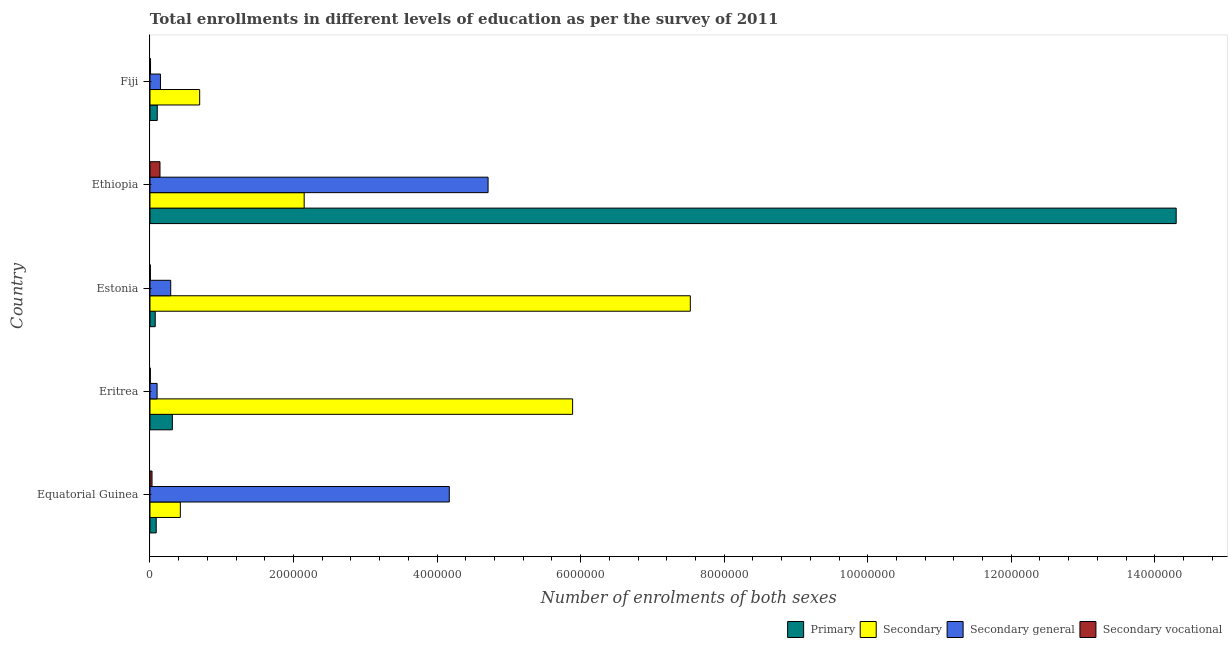Are the number of bars per tick equal to the number of legend labels?
Offer a terse response. Yes. Are the number of bars on each tick of the Y-axis equal?
Give a very brief answer. Yes. What is the label of the 5th group of bars from the top?
Offer a terse response. Equatorial Guinea. What is the number of enrolments in secondary vocational education in Estonia?
Keep it short and to the point. 5330. Across all countries, what is the maximum number of enrolments in secondary general education?
Provide a short and direct response. 4.71e+06. Across all countries, what is the minimum number of enrolments in secondary education?
Give a very brief answer. 4.23e+05. In which country was the number of enrolments in secondary vocational education maximum?
Your response must be concise. Ethiopia. In which country was the number of enrolments in secondary education minimum?
Provide a succinct answer. Equatorial Guinea. What is the total number of enrolments in secondary education in the graph?
Your response must be concise. 1.67e+07. What is the difference between the number of enrolments in secondary education in Eritrea and that in Ethiopia?
Offer a terse response. 3.74e+06. What is the difference between the number of enrolments in primary education in Fiji and the number of enrolments in secondary general education in Equatorial Guinea?
Make the answer very short. -4.07e+06. What is the average number of enrolments in secondary education per country?
Give a very brief answer. 3.34e+06. What is the difference between the number of enrolments in secondary vocational education and number of enrolments in secondary education in Eritrea?
Your response must be concise. -5.88e+06. In how many countries, is the number of enrolments in secondary vocational education greater than 2000000 ?
Your answer should be compact. 0. What is the ratio of the number of enrolments in secondary general education in Eritrea to that in Fiji?
Provide a short and direct response. 0.68. Is the difference between the number of enrolments in secondary general education in Eritrea and Fiji greater than the difference between the number of enrolments in secondary vocational education in Eritrea and Fiji?
Give a very brief answer. No. What is the difference between the highest and the second highest number of enrolments in primary education?
Offer a terse response. 1.40e+07. What is the difference between the highest and the lowest number of enrolments in primary education?
Your answer should be very brief. 1.42e+07. Is the sum of the number of enrolments in primary education in Equatorial Guinea and Fiji greater than the maximum number of enrolments in secondary general education across all countries?
Offer a very short reply. No. What does the 3rd bar from the top in Estonia represents?
Your answer should be very brief. Secondary. What does the 2nd bar from the bottom in Estonia represents?
Provide a succinct answer. Secondary. Are all the bars in the graph horizontal?
Make the answer very short. Yes. What is the difference between two consecutive major ticks on the X-axis?
Provide a succinct answer. 2.00e+06. Does the graph contain grids?
Offer a terse response. No. Where does the legend appear in the graph?
Offer a terse response. Bottom right. How are the legend labels stacked?
Your answer should be very brief. Horizontal. What is the title of the graph?
Your answer should be very brief. Total enrollments in different levels of education as per the survey of 2011. Does "Norway" appear as one of the legend labels in the graph?
Make the answer very short. No. What is the label or title of the X-axis?
Make the answer very short. Number of enrolments of both sexes. What is the Number of enrolments of both sexes of Primary in Equatorial Guinea?
Your answer should be very brief. 8.68e+04. What is the Number of enrolments of both sexes of Secondary in Equatorial Guinea?
Your answer should be very brief. 4.23e+05. What is the Number of enrolments of both sexes of Secondary general in Equatorial Guinea?
Provide a succinct answer. 4.17e+06. What is the Number of enrolments of both sexes in Secondary vocational in Equatorial Guinea?
Offer a very short reply. 2.84e+04. What is the Number of enrolments of both sexes in Primary in Eritrea?
Your response must be concise. 3.12e+05. What is the Number of enrolments of both sexes of Secondary in Eritrea?
Your answer should be compact. 5.89e+06. What is the Number of enrolments of both sexes of Secondary general in Eritrea?
Make the answer very short. 9.89e+04. What is the Number of enrolments of both sexes in Secondary vocational in Eritrea?
Your answer should be very brief. 4541. What is the Number of enrolments of both sexes in Primary in Estonia?
Provide a succinct answer. 7.31e+04. What is the Number of enrolments of both sexes of Secondary in Estonia?
Your response must be concise. 7.53e+06. What is the Number of enrolments of both sexes in Secondary general in Estonia?
Offer a terse response. 2.89e+05. What is the Number of enrolments of both sexes of Secondary vocational in Estonia?
Your answer should be compact. 5330. What is the Number of enrolments of both sexes of Primary in Ethiopia?
Offer a terse response. 1.43e+07. What is the Number of enrolments of both sexes in Secondary in Ethiopia?
Your answer should be compact. 2.15e+06. What is the Number of enrolments of both sexes of Secondary general in Ethiopia?
Your response must be concise. 4.71e+06. What is the Number of enrolments of both sexes of Secondary vocational in Ethiopia?
Offer a very short reply. 1.39e+05. What is the Number of enrolments of both sexes in Primary in Fiji?
Make the answer very short. 1.01e+05. What is the Number of enrolments of both sexes in Secondary in Fiji?
Your answer should be very brief. 6.92e+05. What is the Number of enrolments of both sexes of Secondary general in Fiji?
Ensure brevity in your answer.  1.46e+05. What is the Number of enrolments of both sexes in Secondary vocational in Fiji?
Provide a succinct answer. 7629. Across all countries, what is the maximum Number of enrolments of both sexes of Primary?
Provide a short and direct response. 1.43e+07. Across all countries, what is the maximum Number of enrolments of both sexes of Secondary?
Make the answer very short. 7.53e+06. Across all countries, what is the maximum Number of enrolments of both sexes of Secondary general?
Give a very brief answer. 4.71e+06. Across all countries, what is the maximum Number of enrolments of both sexes in Secondary vocational?
Your answer should be compact. 1.39e+05. Across all countries, what is the minimum Number of enrolments of both sexes in Primary?
Offer a very short reply. 7.31e+04. Across all countries, what is the minimum Number of enrolments of both sexes of Secondary?
Keep it short and to the point. 4.23e+05. Across all countries, what is the minimum Number of enrolments of both sexes of Secondary general?
Offer a very short reply. 9.89e+04. Across all countries, what is the minimum Number of enrolments of both sexes of Secondary vocational?
Your answer should be compact. 4541. What is the total Number of enrolments of both sexes in Primary in the graph?
Your answer should be compact. 1.49e+07. What is the total Number of enrolments of both sexes of Secondary in the graph?
Your answer should be compact. 1.67e+07. What is the total Number of enrolments of both sexes in Secondary general in the graph?
Provide a succinct answer. 9.41e+06. What is the total Number of enrolments of both sexes of Secondary vocational in the graph?
Give a very brief answer. 1.85e+05. What is the difference between the Number of enrolments of both sexes of Primary in Equatorial Guinea and that in Eritrea?
Provide a short and direct response. -2.25e+05. What is the difference between the Number of enrolments of both sexes in Secondary in Equatorial Guinea and that in Eritrea?
Provide a short and direct response. -5.47e+06. What is the difference between the Number of enrolments of both sexes in Secondary general in Equatorial Guinea and that in Eritrea?
Your response must be concise. 4.07e+06. What is the difference between the Number of enrolments of both sexes of Secondary vocational in Equatorial Guinea and that in Eritrea?
Give a very brief answer. 2.38e+04. What is the difference between the Number of enrolments of both sexes in Primary in Equatorial Guinea and that in Estonia?
Ensure brevity in your answer.  1.38e+04. What is the difference between the Number of enrolments of both sexes of Secondary in Equatorial Guinea and that in Estonia?
Your response must be concise. -7.11e+06. What is the difference between the Number of enrolments of both sexes of Secondary general in Equatorial Guinea and that in Estonia?
Ensure brevity in your answer.  3.88e+06. What is the difference between the Number of enrolments of both sexes of Secondary vocational in Equatorial Guinea and that in Estonia?
Offer a terse response. 2.30e+04. What is the difference between the Number of enrolments of both sexes in Primary in Equatorial Guinea and that in Ethiopia?
Your answer should be compact. -1.42e+07. What is the difference between the Number of enrolments of both sexes of Secondary in Equatorial Guinea and that in Ethiopia?
Your response must be concise. -1.73e+06. What is the difference between the Number of enrolments of both sexes in Secondary general in Equatorial Guinea and that in Ethiopia?
Give a very brief answer. -5.40e+05. What is the difference between the Number of enrolments of both sexes in Secondary vocational in Equatorial Guinea and that in Ethiopia?
Your response must be concise. -1.11e+05. What is the difference between the Number of enrolments of both sexes of Primary in Equatorial Guinea and that in Fiji?
Make the answer very short. -1.46e+04. What is the difference between the Number of enrolments of both sexes in Secondary in Equatorial Guinea and that in Fiji?
Ensure brevity in your answer.  -2.69e+05. What is the difference between the Number of enrolments of both sexes of Secondary general in Equatorial Guinea and that in Fiji?
Ensure brevity in your answer.  4.02e+06. What is the difference between the Number of enrolments of both sexes in Secondary vocational in Equatorial Guinea and that in Fiji?
Offer a very short reply. 2.07e+04. What is the difference between the Number of enrolments of both sexes in Primary in Eritrea and that in Estonia?
Offer a very short reply. 2.39e+05. What is the difference between the Number of enrolments of both sexes of Secondary in Eritrea and that in Estonia?
Ensure brevity in your answer.  -1.64e+06. What is the difference between the Number of enrolments of both sexes in Secondary general in Eritrea and that in Estonia?
Make the answer very short. -1.90e+05. What is the difference between the Number of enrolments of both sexes in Secondary vocational in Eritrea and that in Estonia?
Provide a short and direct response. -789. What is the difference between the Number of enrolments of both sexes in Primary in Eritrea and that in Ethiopia?
Offer a very short reply. -1.40e+07. What is the difference between the Number of enrolments of both sexes in Secondary in Eritrea and that in Ethiopia?
Offer a very short reply. 3.74e+06. What is the difference between the Number of enrolments of both sexes in Secondary general in Eritrea and that in Ethiopia?
Make the answer very short. -4.61e+06. What is the difference between the Number of enrolments of both sexes of Secondary vocational in Eritrea and that in Ethiopia?
Your response must be concise. -1.35e+05. What is the difference between the Number of enrolments of both sexes in Primary in Eritrea and that in Fiji?
Make the answer very short. 2.10e+05. What is the difference between the Number of enrolments of both sexes of Secondary in Eritrea and that in Fiji?
Your response must be concise. 5.20e+06. What is the difference between the Number of enrolments of both sexes of Secondary general in Eritrea and that in Fiji?
Provide a short and direct response. -4.72e+04. What is the difference between the Number of enrolments of both sexes of Secondary vocational in Eritrea and that in Fiji?
Your answer should be compact. -3088. What is the difference between the Number of enrolments of both sexes of Primary in Estonia and that in Ethiopia?
Provide a succinct answer. -1.42e+07. What is the difference between the Number of enrolments of both sexes of Secondary in Estonia and that in Ethiopia?
Offer a very short reply. 5.38e+06. What is the difference between the Number of enrolments of both sexes in Secondary general in Estonia and that in Ethiopia?
Your answer should be compact. -4.42e+06. What is the difference between the Number of enrolments of both sexes of Secondary vocational in Estonia and that in Ethiopia?
Keep it short and to the point. -1.34e+05. What is the difference between the Number of enrolments of both sexes in Primary in Estonia and that in Fiji?
Provide a short and direct response. -2.83e+04. What is the difference between the Number of enrolments of both sexes in Secondary in Estonia and that in Fiji?
Your answer should be compact. 6.84e+06. What is the difference between the Number of enrolments of both sexes in Secondary general in Estonia and that in Fiji?
Offer a terse response. 1.43e+05. What is the difference between the Number of enrolments of both sexes in Secondary vocational in Estonia and that in Fiji?
Offer a very short reply. -2299. What is the difference between the Number of enrolments of both sexes in Primary in Ethiopia and that in Fiji?
Offer a terse response. 1.42e+07. What is the difference between the Number of enrolments of both sexes in Secondary in Ethiopia and that in Fiji?
Your answer should be compact. 1.46e+06. What is the difference between the Number of enrolments of both sexes in Secondary general in Ethiopia and that in Fiji?
Keep it short and to the point. 4.56e+06. What is the difference between the Number of enrolments of both sexes in Secondary vocational in Ethiopia and that in Fiji?
Your response must be concise. 1.32e+05. What is the difference between the Number of enrolments of both sexes of Primary in Equatorial Guinea and the Number of enrolments of both sexes of Secondary in Eritrea?
Your answer should be very brief. -5.80e+06. What is the difference between the Number of enrolments of both sexes of Primary in Equatorial Guinea and the Number of enrolments of both sexes of Secondary general in Eritrea?
Your answer should be compact. -1.21e+04. What is the difference between the Number of enrolments of both sexes in Primary in Equatorial Guinea and the Number of enrolments of both sexes in Secondary vocational in Eritrea?
Your answer should be very brief. 8.23e+04. What is the difference between the Number of enrolments of both sexes of Secondary in Equatorial Guinea and the Number of enrolments of both sexes of Secondary general in Eritrea?
Your response must be concise. 3.24e+05. What is the difference between the Number of enrolments of both sexes in Secondary in Equatorial Guinea and the Number of enrolments of both sexes in Secondary vocational in Eritrea?
Your answer should be compact. 4.18e+05. What is the difference between the Number of enrolments of both sexes in Secondary general in Equatorial Guinea and the Number of enrolments of both sexes in Secondary vocational in Eritrea?
Your answer should be very brief. 4.17e+06. What is the difference between the Number of enrolments of both sexes in Primary in Equatorial Guinea and the Number of enrolments of both sexes in Secondary in Estonia?
Offer a terse response. -7.44e+06. What is the difference between the Number of enrolments of both sexes in Primary in Equatorial Guinea and the Number of enrolments of both sexes in Secondary general in Estonia?
Offer a terse response. -2.02e+05. What is the difference between the Number of enrolments of both sexes of Primary in Equatorial Guinea and the Number of enrolments of both sexes of Secondary vocational in Estonia?
Your response must be concise. 8.15e+04. What is the difference between the Number of enrolments of both sexes of Secondary in Equatorial Guinea and the Number of enrolments of both sexes of Secondary general in Estonia?
Keep it short and to the point. 1.34e+05. What is the difference between the Number of enrolments of both sexes of Secondary in Equatorial Guinea and the Number of enrolments of both sexes of Secondary vocational in Estonia?
Give a very brief answer. 4.18e+05. What is the difference between the Number of enrolments of both sexes in Secondary general in Equatorial Guinea and the Number of enrolments of both sexes in Secondary vocational in Estonia?
Keep it short and to the point. 4.16e+06. What is the difference between the Number of enrolments of both sexes of Primary in Equatorial Guinea and the Number of enrolments of both sexes of Secondary in Ethiopia?
Offer a very short reply. -2.06e+06. What is the difference between the Number of enrolments of both sexes of Primary in Equatorial Guinea and the Number of enrolments of both sexes of Secondary general in Ethiopia?
Offer a terse response. -4.62e+06. What is the difference between the Number of enrolments of both sexes in Primary in Equatorial Guinea and the Number of enrolments of both sexes in Secondary vocational in Ethiopia?
Make the answer very short. -5.25e+04. What is the difference between the Number of enrolments of both sexes of Secondary in Equatorial Guinea and the Number of enrolments of both sexes of Secondary general in Ethiopia?
Offer a very short reply. -4.29e+06. What is the difference between the Number of enrolments of both sexes in Secondary in Equatorial Guinea and the Number of enrolments of both sexes in Secondary vocational in Ethiopia?
Offer a very short reply. 2.84e+05. What is the difference between the Number of enrolments of both sexes in Secondary general in Equatorial Guinea and the Number of enrolments of both sexes in Secondary vocational in Ethiopia?
Your answer should be compact. 4.03e+06. What is the difference between the Number of enrolments of both sexes in Primary in Equatorial Guinea and the Number of enrolments of both sexes in Secondary in Fiji?
Your answer should be compact. -6.05e+05. What is the difference between the Number of enrolments of both sexes in Primary in Equatorial Guinea and the Number of enrolments of both sexes in Secondary general in Fiji?
Your response must be concise. -5.93e+04. What is the difference between the Number of enrolments of both sexes of Primary in Equatorial Guinea and the Number of enrolments of both sexes of Secondary vocational in Fiji?
Ensure brevity in your answer.  7.92e+04. What is the difference between the Number of enrolments of both sexes of Secondary in Equatorial Guinea and the Number of enrolments of both sexes of Secondary general in Fiji?
Provide a short and direct response. 2.77e+05. What is the difference between the Number of enrolments of both sexes of Secondary in Equatorial Guinea and the Number of enrolments of both sexes of Secondary vocational in Fiji?
Ensure brevity in your answer.  4.15e+05. What is the difference between the Number of enrolments of both sexes in Secondary general in Equatorial Guinea and the Number of enrolments of both sexes in Secondary vocational in Fiji?
Provide a succinct answer. 4.16e+06. What is the difference between the Number of enrolments of both sexes in Primary in Eritrea and the Number of enrolments of both sexes in Secondary in Estonia?
Ensure brevity in your answer.  -7.22e+06. What is the difference between the Number of enrolments of both sexes in Primary in Eritrea and the Number of enrolments of both sexes in Secondary general in Estonia?
Provide a succinct answer. 2.30e+04. What is the difference between the Number of enrolments of both sexes in Primary in Eritrea and the Number of enrolments of both sexes in Secondary vocational in Estonia?
Make the answer very short. 3.06e+05. What is the difference between the Number of enrolments of both sexes in Secondary in Eritrea and the Number of enrolments of both sexes in Secondary general in Estonia?
Make the answer very short. 5.60e+06. What is the difference between the Number of enrolments of both sexes in Secondary in Eritrea and the Number of enrolments of both sexes in Secondary vocational in Estonia?
Keep it short and to the point. 5.88e+06. What is the difference between the Number of enrolments of both sexes of Secondary general in Eritrea and the Number of enrolments of both sexes of Secondary vocational in Estonia?
Your answer should be very brief. 9.36e+04. What is the difference between the Number of enrolments of both sexes of Primary in Eritrea and the Number of enrolments of both sexes of Secondary in Ethiopia?
Your answer should be very brief. -1.84e+06. What is the difference between the Number of enrolments of both sexes of Primary in Eritrea and the Number of enrolments of both sexes of Secondary general in Ethiopia?
Your response must be concise. -4.40e+06. What is the difference between the Number of enrolments of both sexes in Primary in Eritrea and the Number of enrolments of both sexes in Secondary vocational in Ethiopia?
Keep it short and to the point. 1.72e+05. What is the difference between the Number of enrolments of both sexes of Secondary in Eritrea and the Number of enrolments of both sexes of Secondary general in Ethiopia?
Provide a short and direct response. 1.18e+06. What is the difference between the Number of enrolments of both sexes in Secondary in Eritrea and the Number of enrolments of both sexes in Secondary vocational in Ethiopia?
Your answer should be very brief. 5.75e+06. What is the difference between the Number of enrolments of both sexes in Secondary general in Eritrea and the Number of enrolments of both sexes in Secondary vocational in Ethiopia?
Make the answer very short. -4.04e+04. What is the difference between the Number of enrolments of both sexes in Primary in Eritrea and the Number of enrolments of both sexes in Secondary in Fiji?
Give a very brief answer. -3.81e+05. What is the difference between the Number of enrolments of both sexes in Primary in Eritrea and the Number of enrolments of both sexes in Secondary general in Fiji?
Your answer should be compact. 1.66e+05. What is the difference between the Number of enrolments of both sexes in Primary in Eritrea and the Number of enrolments of both sexes in Secondary vocational in Fiji?
Provide a succinct answer. 3.04e+05. What is the difference between the Number of enrolments of both sexes of Secondary in Eritrea and the Number of enrolments of both sexes of Secondary general in Fiji?
Ensure brevity in your answer.  5.74e+06. What is the difference between the Number of enrolments of both sexes of Secondary in Eritrea and the Number of enrolments of both sexes of Secondary vocational in Fiji?
Your answer should be compact. 5.88e+06. What is the difference between the Number of enrolments of both sexes in Secondary general in Eritrea and the Number of enrolments of both sexes in Secondary vocational in Fiji?
Provide a succinct answer. 9.13e+04. What is the difference between the Number of enrolments of both sexes in Primary in Estonia and the Number of enrolments of both sexes in Secondary in Ethiopia?
Ensure brevity in your answer.  -2.08e+06. What is the difference between the Number of enrolments of both sexes of Primary in Estonia and the Number of enrolments of both sexes of Secondary general in Ethiopia?
Make the answer very short. -4.64e+06. What is the difference between the Number of enrolments of both sexes in Primary in Estonia and the Number of enrolments of both sexes in Secondary vocational in Ethiopia?
Your answer should be compact. -6.63e+04. What is the difference between the Number of enrolments of both sexes of Secondary in Estonia and the Number of enrolments of both sexes of Secondary general in Ethiopia?
Keep it short and to the point. 2.82e+06. What is the difference between the Number of enrolments of both sexes in Secondary in Estonia and the Number of enrolments of both sexes in Secondary vocational in Ethiopia?
Provide a short and direct response. 7.39e+06. What is the difference between the Number of enrolments of both sexes of Secondary general in Estonia and the Number of enrolments of both sexes of Secondary vocational in Ethiopia?
Offer a terse response. 1.49e+05. What is the difference between the Number of enrolments of both sexes in Primary in Estonia and the Number of enrolments of both sexes in Secondary in Fiji?
Your answer should be very brief. -6.19e+05. What is the difference between the Number of enrolments of both sexes of Primary in Estonia and the Number of enrolments of both sexes of Secondary general in Fiji?
Provide a short and direct response. -7.30e+04. What is the difference between the Number of enrolments of both sexes of Primary in Estonia and the Number of enrolments of both sexes of Secondary vocational in Fiji?
Make the answer very short. 6.54e+04. What is the difference between the Number of enrolments of both sexes of Secondary in Estonia and the Number of enrolments of both sexes of Secondary general in Fiji?
Your response must be concise. 7.38e+06. What is the difference between the Number of enrolments of both sexes in Secondary in Estonia and the Number of enrolments of both sexes in Secondary vocational in Fiji?
Give a very brief answer. 7.52e+06. What is the difference between the Number of enrolments of both sexes in Secondary general in Estonia and the Number of enrolments of both sexes in Secondary vocational in Fiji?
Your answer should be compact. 2.81e+05. What is the difference between the Number of enrolments of both sexes in Primary in Ethiopia and the Number of enrolments of both sexes in Secondary in Fiji?
Offer a terse response. 1.36e+07. What is the difference between the Number of enrolments of both sexes in Primary in Ethiopia and the Number of enrolments of both sexes in Secondary general in Fiji?
Your answer should be compact. 1.42e+07. What is the difference between the Number of enrolments of both sexes in Primary in Ethiopia and the Number of enrolments of both sexes in Secondary vocational in Fiji?
Your answer should be very brief. 1.43e+07. What is the difference between the Number of enrolments of both sexes of Secondary in Ethiopia and the Number of enrolments of both sexes of Secondary general in Fiji?
Ensure brevity in your answer.  2.00e+06. What is the difference between the Number of enrolments of both sexes of Secondary in Ethiopia and the Number of enrolments of both sexes of Secondary vocational in Fiji?
Provide a succinct answer. 2.14e+06. What is the difference between the Number of enrolments of both sexes of Secondary general in Ethiopia and the Number of enrolments of both sexes of Secondary vocational in Fiji?
Offer a terse response. 4.70e+06. What is the average Number of enrolments of both sexes of Primary per country?
Offer a very short reply. 2.97e+06. What is the average Number of enrolments of both sexes of Secondary per country?
Offer a very short reply. 3.34e+06. What is the average Number of enrolments of both sexes in Secondary general per country?
Keep it short and to the point. 1.88e+06. What is the average Number of enrolments of both sexes of Secondary vocational per country?
Keep it short and to the point. 3.70e+04. What is the difference between the Number of enrolments of both sexes in Primary and Number of enrolments of both sexes in Secondary in Equatorial Guinea?
Your answer should be very brief. -3.36e+05. What is the difference between the Number of enrolments of both sexes in Primary and Number of enrolments of both sexes in Secondary general in Equatorial Guinea?
Offer a terse response. -4.08e+06. What is the difference between the Number of enrolments of both sexes in Primary and Number of enrolments of both sexes in Secondary vocational in Equatorial Guinea?
Give a very brief answer. 5.84e+04. What is the difference between the Number of enrolments of both sexes of Secondary and Number of enrolments of both sexes of Secondary general in Equatorial Guinea?
Provide a short and direct response. -3.75e+06. What is the difference between the Number of enrolments of both sexes in Secondary and Number of enrolments of both sexes in Secondary vocational in Equatorial Guinea?
Ensure brevity in your answer.  3.95e+05. What is the difference between the Number of enrolments of both sexes of Secondary general and Number of enrolments of both sexes of Secondary vocational in Equatorial Guinea?
Provide a short and direct response. 4.14e+06. What is the difference between the Number of enrolments of both sexes in Primary and Number of enrolments of both sexes in Secondary in Eritrea?
Offer a terse response. -5.58e+06. What is the difference between the Number of enrolments of both sexes in Primary and Number of enrolments of both sexes in Secondary general in Eritrea?
Provide a succinct answer. 2.13e+05. What is the difference between the Number of enrolments of both sexes of Primary and Number of enrolments of both sexes of Secondary vocational in Eritrea?
Offer a very short reply. 3.07e+05. What is the difference between the Number of enrolments of both sexes of Secondary and Number of enrolments of both sexes of Secondary general in Eritrea?
Give a very brief answer. 5.79e+06. What is the difference between the Number of enrolments of both sexes of Secondary and Number of enrolments of both sexes of Secondary vocational in Eritrea?
Your answer should be very brief. 5.88e+06. What is the difference between the Number of enrolments of both sexes of Secondary general and Number of enrolments of both sexes of Secondary vocational in Eritrea?
Your answer should be very brief. 9.43e+04. What is the difference between the Number of enrolments of both sexes of Primary and Number of enrolments of both sexes of Secondary in Estonia?
Your answer should be compact. -7.46e+06. What is the difference between the Number of enrolments of both sexes of Primary and Number of enrolments of both sexes of Secondary general in Estonia?
Your answer should be compact. -2.16e+05. What is the difference between the Number of enrolments of both sexes in Primary and Number of enrolments of both sexes in Secondary vocational in Estonia?
Your answer should be compact. 6.77e+04. What is the difference between the Number of enrolments of both sexes in Secondary and Number of enrolments of both sexes in Secondary general in Estonia?
Keep it short and to the point. 7.24e+06. What is the difference between the Number of enrolments of both sexes in Secondary and Number of enrolments of both sexes in Secondary vocational in Estonia?
Make the answer very short. 7.52e+06. What is the difference between the Number of enrolments of both sexes of Secondary general and Number of enrolments of both sexes of Secondary vocational in Estonia?
Ensure brevity in your answer.  2.83e+05. What is the difference between the Number of enrolments of both sexes of Primary and Number of enrolments of both sexes of Secondary in Ethiopia?
Your answer should be very brief. 1.21e+07. What is the difference between the Number of enrolments of both sexes in Primary and Number of enrolments of both sexes in Secondary general in Ethiopia?
Provide a succinct answer. 9.59e+06. What is the difference between the Number of enrolments of both sexes in Primary and Number of enrolments of both sexes in Secondary vocational in Ethiopia?
Make the answer very short. 1.42e+07. What is the difference between the Number of enrolments of both sexes of Secondary and Number of enrolments of both sexes of Secondary general in Ethiopia?
Offer a very short reply. -2.56e+06. What is the difference between the Number of enrolments of both sexes in Secondary and Number of enrolments of both sexes in Secondary vocational in Ethiopia?
Ensure brevity in your answer.  2.01e+06. What is the difference between the Number of enrolments of both sexes in Secondary general and Number of enrolments of both sexes in Secondary vocational in Ethiopia?
Offer a terse response. 4.57e+06. What is the difference between the Number of enrolments of both sexes in Primary and Number of enrolments of both sexes in Secondary in Fiji?
Your answer should be compact. -5.91e+05. What is the difference between the Number of enrolments of both sexes in Primary and Number of enrolments of both sexes in Secondary general in Fiji?
Offer a very short reply. -4.47e+04. What is the difference between the Number of enrolments of both sexes in Primary and Number of enrolments of both sexes in Secondary vocational in Fiji?
Your response must be concise. 9.38e+04. What is the difference between the Number of enrolments of both sexes in Secondary and Number of enrolments of both sexes in Secondary general in Fiji?
Offer a terse response. 5.46e+05. What is the difference between the Number of enrolments of both sexes of Secondary and Number of enrolments of both sexes of Secondary vocational in Fiji?
Your answer should be compact. 6.85e+05. What is the difference between the Number of enrolments of both sexes of Secondary general and Number of enrolments of both sexes of Secondary vocational in Fiji?
Provide a succinct answer. 1.38e+05. What is the ratio of the Number of enrolments of both sexes of Primary in Equatorial Guinea to that in Eritrea?
Your answer should be compact. 0.28. What is the ratio of the Number of enrolments of both sexes in Secondary in Equatorial Guinea to that in Eritrea?
Offer a very short reply. 0.07. What is the ratio of the Number of enrolments of both sexes of Secondary general in Equatorial Guinea to that in Eritrea?
Your answer should be very brief. 42.17. What is the ratio of the Number of enrolments of both sexes of Secondary vocational in Equatorial Guinea to that in Eritrea?
Your answer should be compact. 6.25. What is the ratio of the Number of enrolments of both sexes of Primary in Equatorial Guinea to that in Estonia?
Give a very brief answer. 1.19. What is the ratio of the Number of enrolments of both sexes in Secondary in Equatorial Guinea to that in Estonia?
Keep it short and to the point. 0.06. What is the ratio of the Number of enrolments of both sexes in Secondary general in Equatorial Guinea to that in Estonia?
Your answer should be very brief. 14.44. What is the ratio of the Number of enrolments of both sexes of Secondary vocational in Equatorial Guinea to that in Estonia?
Your answer should be compact. 5.32. What is the ratio of the Number of enrolments of both sexes in Primary in Equatorial Guinea to that in Ethiopia?
Make the answer very short. 0.01. What is the ratio of the Number of enrolments of both sexes of Secondary in Equatorial Guinea to that in Ethiopia?
Your response must be concise. 0.2. What is the ratio of the Number of enrolments of both sexes of Secondary general in Equatorial Guinea to that in Ethiopia?
Offer a terse response. 0.89. What is the ratio of the Number of enrolments of both sexes of Secondary vocational in Equatorial Guinea to that in Ethiopia?
Ensure brevity in your answer.  0.2. What is the ratio of the Number of enrolments of both sexes of Primary in Equatorial Guinea to that in Fiji?
Ensure brevity in your answer.  0.86. What is the ratio of the Number of enrolments of both sexes of Secondary in Equatorial Guinea to that in Fiji?
Make the answer very short. 0.61. What is the ratio of the Number of enrolments of both sexes of Secondary general in Equatorial Guinea to that in Fiji?
Keep it short and to the point. 28.55. What is the ratio of the Number of enrolments of both sexes in Secondary vocational in Equatorial Guinea to that in Fiji?
Give a very brief answer. 3.72. What is the ratio of the Number of enrolments of both sexes of Primary in Eritrea to that in Estonia?
Make the answer very short. 4.27. What is the ratio of the Number of enrolments of both sexes of Secondary in Eritrea to that in Estonia?
Make the answer very short. 0.78. What is the ratio of the Number of enrolments of both sexes of Secondary general in Eritrea to that in Estonia?
Offer a very short reply. 0.34. What is the ratio of the Number of enrolments of both sexes in Secondary vocational in Eritrea to that in Estonia?
Ensure brevity in your answer.  0.85. What is the ratio of the Number of enrolments of both sexes of Primary in Eritrea to that in Ethiopia?
Offer a very short reply. 0.02. What is the ratio of the Number of enrolments of both sexes in Secondary in Eritrea to that in Ethiopia?
Make the answer very short. 2.74. What is the ratio of the Number of enrolments of both sexes of Secondary general in Eritrea to that in Ethiopia?
Your response must be concise. 0.02. What is the ratio of the Number of enrolments of both sexes of Secondary vocational in Eritrea to that in Ethiopia?
Ensure brevity in your answer.  0.03. What is the ratio of the Number of enrolments of both sexes of Primary in Eritrea to that in Fiji?
Keep it short and to the point. 3.07. What is the ratio of the Number of enrolments of both sexes in Secondary in Eritrea to that in Fiji?
Ensure brevity in your answer.  8.51. What is the ratio of the Number of enrolments of both sexes in Secondary general in Eritrea to that in Fiji?
Your answer should be compact. 0.68. What is the ratio of the Number of enrolments of both sexes of Secondary vocational in Eritrea to that in Fiji?
Keep it short and to the point. 0.6. What is the ratio of the Number of enrolments of both sexes of Primary in Estonia to that in Ethiopia?
Your response must be concise. 0.01. What is the ratio of the Number of enrolments of both sexes in Secondary in Estonia to that in Ethiopia?
Your answer should be very brief. 3.5. What is the ratio of the Number of enrolments of both sexes in Secondary general in Estonia to that in Ethiopia?
Give a very brief answer. 0.06. What is the ratio of the Number of enrolments of both sexes of Secondary vocational in Estonia to that in Ethiopia?
Offer a very short reply. 0.04. What is the ratio of the Number of enrolments of both sexes in Primary in Estonia to that in Fiji?
Your answer should be very brief. 0.72. What is the ratio of the Number of enrolments of both sexes in Secondary in Estonia to that in Fiji?
Keep it short and to the point. 10.87. What is the ratio of the Number of enrolments of both sexes of Secondary general in Estonia to that in Fiji?
Provide a succinct answer. 1.98. What is the ratio of the Number of enrolments of both sexes in Secondary vocational in Estonia to that in Fiji?
Ensure brevity in your answer.  0.7. What is the ratio of the Number of enrolments of both sexes of Primary in Ethiopia to that in Fiji?
Ensure brevity in your answer.  141.03. What is the ratio of the Number of enrolments of both sexes of Secondary in Ethiopia to that in Fiji?
Your answer should be compact. 3.1. What is the ratio of the Number of enrolments of both sexes of Secondary general in Ethiopia to that in Fiji?
Ensure brevity in your answer.  32.25. What is the ratio of the Number of enrolments of both sexes in Secondary vocational in Ethiopia to that in Fiji?
Your answer should be very brief. 18.26. What is the difference between the highest and the second highest Number of enrolments of both sexes in Primary?
Keep it short and to the point. 1.40e+07. What is the difference between the highest and the second highest Number of enrolments of both sexes of Secondary?
Provide a succinct answer. 1.64e+06. What is the difference between the highest and the second highest Number of enrolments of both sexes of Secondary general?
Offer a very short reply. 5.40e+05. What is the difference between the highest and the second highest Number of enrolments of both sexes in Secondary vocational?
Offer a terse response. 1.11e+05. What is the difference between the highest and the lowest Number of enrolments of both sexes in Primary?
Offer a terse response. 1.42e+07. What is the difference between the highest and the lowest Number of enrolments of both sexes of Secondary?
Your answer should be very brief. 7.11e+06. What is the difference between the highest and the lowest Number of enrolments of both sexes of Secondary general?
Offer a terse response. 4.61e+06. What is the difference between the highest and the lowest Number of enrolments of both sexes of Secondary vocational?
Keep it short and to the point. 1.35e+05. 